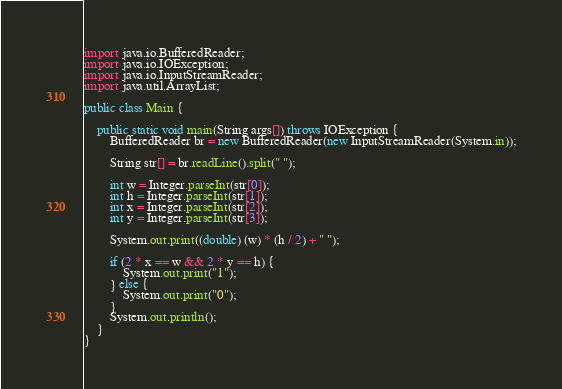Convert code to text. <code><loc_0><loc_0><loc_500><loc_500><_Java_>import java.io.BufferedReader;
import java.io.IOException;
import java.io.InputStreamReader;
import java.util.ArrayList;

public class Main {

	public static void main(String args[]) throws IOException {
		BufferedReader br = new BufferedReader(new InputStreamReader(System.in));

		String str[] = br.readLine().split(" ");

		int w = Integer.parseInt(str[0]);
		int h = Integer.parseInt(str[1]);
		int x = Integer.parseInt(str[2]);
		int y = Integer.parseInt(str[3]);

		System.out.print((double) (w) * (h / 2) + " ");

		if (2 * x == w && 2 * y == h) {
			System.out.print("1");
		} else {
			System.out.print("0");
		}
		System.out.println();
	}
}
</code> 